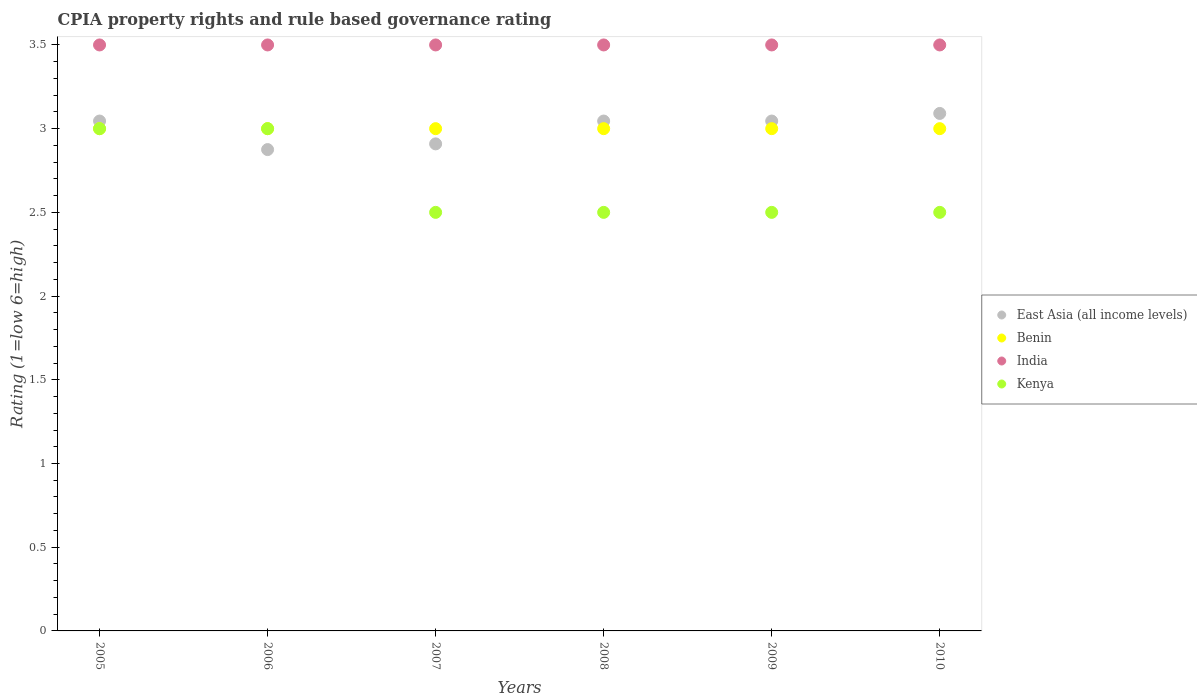Is the number of dotlines equal to the number of legend labels?
Keep it short and to the point. Yes. What is the CPIA rating in East Asia (all income levels) in 2007?
Your answer should be very brief. 2.91. Across all years, what is the maximum CPIA rating in Kenya?
Make the answer very short. 3. Across all years, what is the minimum CPIA rating in Kenya?
Ensure brevity in your answer.  2.5. In which year was the CPIA rating in Kenya maximum?
Make the answer very short. 2005. In which year was the CPIA rating in Benin minimum?
Your response must be concise. 2005. What is the total CPIA rating in Benin in the graph?
Ensure brevity in your answer.  18. In how many years, is the CPIA rating in Kenya greater than 1.5?
Provide a short and direct response. 6. What is the ratio of the CPIA rating in East Asia (all income levels) in 2006 to that in 2008?
Offer a very short reply. 0.94. What is the difference between the highest and the second highest CPIA rating in India?
Offer a terse response. 0. What is the difference between the highest and the lowest CPIA rating in Benin?
Provide a succinct answer. 0. In how many years, is the CPIA rating in Kenya greater than the average CPIA rating in Kenya taken over all years?
Ensure brevity in your answer.  2. Is the CPIA rating in Kenya strictly greater than the CPIA rating in East Asia (all income levels) over the years?
Your answer should be compact. No. How many dotlines are there?
Offer a very short reply. 4. Are the values on the major ticks of Y-axis written in scientific E-notation?
Give a very brief answer. No. Where does the legend appear in the graph?
Your answer should be compact. Center right. How are the legend labels stacked?
Offer a very short reply. Vertical. What is the title of the graph?
Your answer should be compact. CPIA property rights and rule based governance rating. Does "China" appear as one of the legend labels in the graph?
Ensure brevity in your answer.  No. What is the label or title of the X-axis?
Give a very brief answer. Years. What is the label or title of the Y-axis?
Offer a terse response. Rating (1=low 6=high). What is the Rating (1=low 6=high) in East Asia (all income levels) in 2005?
Offer a terse response. 3.05. What is the Rating (1=low 6=high) of Benin in 2005?
Your answer should be very brief. 3. What is the Rating (1=low 6=high) of India in 2005?
Ensure brevity in your answer.  3.5. What is the Rating (1=low 6=high) of Kenya in 2005?
Your answer should be very brief. 3. What is the Rating (1=low 6=high) of East Asia (all income levels) in 2006?
Your answer should be compact. 2.88. What is the Rating (1=low 6=high) in Benin in 2006?
Your answer should be compact. 3. What is the Rating (1=low 6=high) of Kenya in 2006?
Ensure brevity in your answer.  3. What is the Rating (1=low 6=high) of East Asia (all income levels) in 2007?
Provide a succinct answer. 2.91. What is the Rating (1=low 6=high) of India in 2007?
Make the answer very short. 3.5. What is the Rating (1=low 6=high) in Kenya in 2007?
Ensure brevity in your answer.  2.5. What is the Rating (1=low 6=high) in East Asia (all income levels) in 2008?
Make the answer very short. 3.05. What is the Rating (1=low 6=high) in East Asia (all income levels) in 2009?
Make the answer very short. 3.05. What is the Rating (1=low 6=high) of Benin in 2009?
Ensure brevity in your answer.  3. What is the Rating (1=low 6=high) in India in 2009?
Make the answer very short. 3.5. What is the Rating (1=low 6=high) of East Asia (all income levels) in 2010?
Keep it short and to the point. 3.09. What is the Rating (1=low 6=high) of Benin in 2010?
Offer a very short reply. 3. What is the Rating (1=low 6=high) of India in 2010?
Offer a very short reply. 3.5. What is the Rating (1=low 6=high) in Kenya in 2010?
Give a very brief answer. 2.5. Across all years, what is the maximum Rating (1=low 6=high) of East Asia (all income levels)?
Make the answer very short. 3.09. Across all years, what is the maximum Rating (1=low 6=high) in Kenya?
Provide a short and direct response. 3. Across all years, what is the minimum Rating (1=low 6=high) in East Asia (all income levels)?
Keep it short and to the point. 2.88. Across all years, what is the minimum Rating (1=low 6=high) in Benin?
Offer a terse response. 3. Across all years, what is the minimum Rating (1=low 6=high) in India?
Ensure brevity in your answer.  3.5. Across all years, what is the minimum Rating (1=low 6=high) in Kenya?
Offer a very short reply. 2.5. What is the total Rating (1=low 6=high) in East Asia (all income levels) in the graph?
Offer a very short reply. 18.01. What is the total Rating (1=low 6=high) in Benin in the graph?
Your answer should be very brief. 18. What is the total Rating (1=low 6=high) of India in the graph?
Offer a terse response. 21. What is the total Rating (1=low 6=high) in Kenya in the graph?
Offer a very short reply. 16. What is the difference between the Rating (1=low 6=high) in East Asia (all income levels) in 2005 and that in 2006?
Make the answer very short. 0.17. What is the difference between the Rating (1=low 6=high) of India in 2005 and that in 2006?
Provide a succinct answer. 0. What is the difference between the Rating (1=low 6=high) of East Asia (all income levels) in 2005 and that in 2007?
Your response must be concise. 0.14. What is the difference between the Rating (1=low 6=high) in Benin in 2005 and that in 2007?
Make the answer very short. 0. What is the difference between the Rating (1=low 6=high) of India in 2005 and that in 2007?
Give a very brief answer. 0. What is the difference between the Rating (1=low 6=high) of Kenya in 2005 and that in 2007?
Your answer should be compact. 0.5. What is the difference between the Rating (1=low 6=high) of India in 2005 and that in 2008?
Offer a terse response. 0. What is the difference between the Rating (1=low 6=high) in Kenya in 2005 and that in 2008?
Your answer should be very brief. 0.5. What is the difference between the Rating (1=low 6=high) of East Asia (all income levels) in 2005 and that in 2009?
Ensure brevity in your answer.  0. What is the difference between the Rating (1=low 6=high) of Benin in 2005 and that in 2009?
Your response must be concise. 0. What is the difference between the Rating (1=low 6=high) of East Asia (all income levels) in 2005 and that in 2010?
Keep it short and to the point. -0.05. What is the difference between the Rating (1=low 6=high) of East Asia (all income levels) in 2006 and that in 2007?
Provide a succinct answer. -0.03. What is the difference between the Rating (1=low 6=high) of Benin in 2006 and that in 2007?
Ensure brevity in your answer.  0. What is the difference between the Rating (1=low 6=high) in Kenya in 2006 and that in 2007?
Offer a very short reply. 0.5. What is the difference between the Rating (1=low 6=high) of East Asia (all income levels) in 2006 and that in 2008?
Provide a short and direct response. -0.17. What is the difference between the Rating (1=low 6=high) in India in 2006 and that in 2008?
Offer a very short reply. 0. What is the difference between the Rating (1=low 6=high) in Kenya in 2006 and that in 2008?
Ensure brevity in your answer.  0.5. What is the difference between the Rating (1=low 6=high) of East Asia (all income levels) in 2006 and that in 2009?
Offer a very short reply. -0.17. What is the difference between the Rating (1=low 6=high) in East Asia (all income levels) in 2006 and that in 2010?
Make the answer very short. -0.22. What is the difference between the Rating (1=low 6=high) in Kenya in 2006 and that in 2010?
Give a very brief answer. 0.5. What is the difference between the Rating (1=low 6=high) of East Asia (all income levels) in 2007 and that in 2008?
Provide a short and direct response. -0.14. What is the difference between the Rating (1=low 6=high) in Benin in 2007 and that in 2008?
Provide a short and direct response. 0. What is the difference between the Rating (1=low 6=high) in India in 2007 and that in 2008?
Keep it short and to the point. 0. What is the difference between the Rating (1=low 6=high) of Kenya in 2007 and that in 2008?
Offer a very short reply. 0. What is the difference between the Rating (1=low 6=high) of East Asia (all income levels) in 2007 and that in 2009?
Your response must be concise. -0.14. What is the difference between the Rating (1=low 6=high) in Benin in 2007 and that in 2009?
Keep it short and to the point. 0. What is the difference between the Rating (1=low 6=high) in Kenya in 2007 and that in 2009?
Offer a very short reply. 0. What is the difference between the Rating (1=low 6=high) in East Asia (all income levels) in 2007 and that in 2010?
Ensure brevity in your answer.  -0.18. What is the difference between the Rating (1=low 6=high) of Kenya in 2007 and that in 2010?
Offer a terse response. 0. What is the difference between the Rating (1=low 6=high) in Benin in 2008 and that in 2009?
Offer a very short reply. 0. What is the difference between the Rating (1=low 6=high) in India in 2008 and that in 2009?
Keep it short and to the point. 0. What is the difference between the Rating (1=low 6=high) of East Asia (all income levels) in 2008 and that in 2010?
Offer a terse response. -0.05. What is the difference between the Rating (1=low 6=high) of Benin in 2008 and that in 2010?
Keep it short and to the point. 0. What is the difference between the Rating (1=low 6=high) in India in 2008 and that in 2010?
Your answer should be very brief. 0. What is the difference between the Rating (1=low 6=high) of Kenya in 2008 and that in 2010?
Provide a short and direct response. 0. What is the difference between the Rating (1=low 6=high) of East Asia (all income levels) in 2009 and that in 2010?
Keep it short and to the point. -0.05. What is the difference between the Rating (1=low 6=high) of India in 2009 and that in 2010?
Offer a very short reply. 0. What is the difference between the Rating (1=low 6=high) of Kenya in 2009 and that in 2010?
Give a very brief answer. 0. What is the difference between the Rating (1=low 6=high) in East Asia (all income levels) in 2005 and the Rating (1=low 6=high) in Benin in 2006?
Provide a short and direct response. 0.05. What is the difference between the Rating (1=low 6=high) in East Asia (all income levels) in 2005 and the Rating (1=low 6=high) in India in 2006?
Ensure brevity in your answer.  -0.45. What is the difference between the Rating (1=low 6=high) of East Asia (all income levels) in 2005 and the Rating (1=low 6=high) of Kenya in 2006?
Your answer should be very brief. 0.05. What is the difference between the Rating (1=low 6=high) of Benin in 2005 and the Rating (1=low 6=high) of India in 2006?
Provide a short and direct response. -0.5. What is the difference between the Rating (1=low 6=high) of East Asia (all income levels) in 2005 and the Rating (1=low 6=high) of Benin in 2007?
Your answer should be very brief. 0.05. What is the difference between the Rating (1=low 6=high) of East Asia (all income levels) in 2005 and the Rating (1=low 6=high) of India in 2007?
Give a very brief answer. -0.45. What is the difference between the Rating (1=low 6=high) of East Asia (all income levels) in 2005 and the Rating (1=low 6=high) of Kenya in 2007?
Make the answer very short. 0.55. What is the difference between the Rating (1=low 6=high) of East Asia (all income levels) in 2005 and the Rating (1=low 6=high) of Benin in 2008?
Keep it short and to the point. 0.05. What is the difference between the Rating (1=low 6=high) in East Asia (all income levels) in 2005 and the Rating (1=low 6=high) in India in 2008?
Ensure brevity in your answer.  -0.45. What is the difference between the Rating (1=low 6=high) in East Asia (all income levels) in 2005 and the Rating (1=low 6=high) in Kenya in 2008?
Your response must be concise. 0.55. What is the difference between the Rating (1=low 6=high) of Benin in 2005 and the Rating (1=low 6=high) of Kenya in 2008?
Provide a succinct answer. 0.5. What is the difference between the Rating (1=low 6=high) of East Asia (all income levels) in 2005 and the Rating (1=low 6=high) of Benin in 2009?
Your answer should be compact. 0.05. What is the difference between the Rating (1=low 6=high) of East Asia (all income levels) in 2005 and the Rating (1=low 6=high) of India in 2009?
Offer a terse response. -0.45. What is the difference between the Rating (1=low 6=high) of East Asia (all income levels) in 2005 and the Rating (1=low 6=high) of Kenya in 2009?
Provide a short and direct response. 0.55. What is the difference between the Rating (1=low 6=high) of Benin in 2005 and the Rating (1=low 6=high) of Kenya in 2009?
Offer a terse response. 0.5. What is the difference between the Rating (1=low 6=high) in India in 2005 and the Rating (1=low 6=high) in Kenya in 2009?
Make the answer very short. 1. What is the difference between the Rating (1=low 6=high) of East Asia (all income levels) in 2005 and the Rating (1=low 6=high) of Benin in 2010?
Give a very brief answer. 0.05. What is the difference between the Rating (1=low 6=high) in East Asia (all income levels) in 2005 and the Rating (1=low 6=high) in India in 2010?
Give a very brief answer. -0.45. What is the difference between the Rating (1=low 6=high) of East Asia (all income levels) in 2005 and the Rating (1=low 6=high) of Kenya in 2010?
Offer a very short reply. 0.55. What is the difference between the Rating (1=low 6=high) of Benin in 2005 and the Rating (1=low 6=high) of India in 2010?
Keep it short and to the point. -0.5. What is the difference between the Rating (1=low 6=high) in Benin in 2005 and the Rating (1=low 6=high) in Kenya in 2010?
Ensure brevity in your answer.  0.5. What is the difference between the Rating (1=low 6=high) in East Asia (all income levels) in 2006 and the Rating (1=low 6=high) in Benin in 2007?
Your answer should be very brief. -0.12. What is the difference between the Rating (1=low 6=high) of East Asia (all income levels) in 2006 and the Rating (1=low 6=high) of India in 2007?
Give a very brief answer. -0.62. What is the difference between the Rating (1=low 6=high) of East Asia (all income levels) in 2006 and the Rating (1=low 6=high) of Kenya in 2007?
Your response must be concise. 0.38. What is the difference between the Rating (1=low 6=high) of India in 2006 and the Rating (1=low 6=high) of Kenya in 2007?
Ensure brevity in your answer.  1. What is the difference between the Rating (1=low 6=high) of East Asia (all income levels) in 2006 and the Rating (1=low 6=high) of Benin in 2008?
Give a very brief answer. -0.12. What is the difference between the Rating (1=low 6=high) of East Asia (all income levels) in 2006 and the Rating (1=low 6=high) of India in 2008?
Keep it short and to the point. -0.62. What is the difference between the Rating (1=low 6=high) of Benin in 2006 and the Rating (1=low 6=high) of Kenya in 2008?
Provide a short and direct response. 0.5. What is the difference between the Rating (1=low 6=high) of East Asia (all income levels) in 2006 and the Rating (1=low 6=high) of Benin in 2009?
Provide a short and direct response. -0.12. What is the difference between the Rating (1=low 6=high) in East Asia (all income levels) in 2006 and the Rating (1=low 6=high) in India in 2009?
Make the answer very short. -0.62. What is the difference between the Rating (1=low 6=high) of Benin in 2006 and the Rating (1=low 6=high) of Kenya in 2009?
Your answer should be very brief. 0.5. What is the difference between the Rating (1=low 6=high) of India in 2006 and the Rating (1=low 6=high) of Kenya in 2009?
Your answer should be compact. 1. What is the difference between the Rating (1=low 6=high) in East Asia (all income levels) in 2006 and the Rating (1=low 6=high) in Benin in 2010?
Offer a terse response. -0.12. What is the difference between the Rating (1=low 6=high) of East Asia (all income levels) in 2006 and the Rating (1=low 6=high) of India in 2010?
Offer a terse response. -0.62. What is the difference between the Rating (1=low 6=high) in Benin in 2006 and the Rating (1=low 6=high) in India in 2010?
Ensure brevity in your answer.  -0.5. What is the difference between the Rating (1=low 6=high) in Benin in 2006 and the Rating (1=low 6=high) in Kenya in 2010?
Provide a succinct answer. 0.5. What is the difference between the Rating (1=low 6=high) of East Asia (all income levels) in 2007 and the Rating (1=low 6=high) of Benin in 2008?
Your answer should be compact. -0.09. What is the difference between the Rating (1=low 6=high) in East Asia (all income levels) in 2007 and the Rating (1=low 6=high) in India in 2008?
Provide a succinct answer. -0.59. What is the difference between the Rating (1=low 6=high) of East Asia (all income levels) in 2007 and the Rating (1=low 6=high) of Kenya in 2008?
Keep it short and to the point. 0.41. What is the difference between the Rating (1=low 6=high) of Benin in 2007 and the Rating (1=low 6=high) of Kenya in 2008?
Make the answer very short. 0.5. What is the difference between the Rating (1=low 6=high) in East Asia (all income levels) in 2007 and the Rating (1=low 6=high) in Benin in 2009?
Give a very brief answer. -0.09. What is the difference between the Rating (1=low 6=high) of East Asia (all income levels) in 2007 and the Rating (1=low 6=high) of India in 2009?
Ensure brevity in your answer.  -0.59. What is the difference between the Rating (1=low 6=high) of East Asia (all income levels) in 2007 and the Rating (1=low 6=high) of Kenya in 2009?
Make the answer very short. 0.41. What is the difference between the Rating (1=low 6=high) in Benin in 2007 and the Rating (1=low 6=high) in India in 2009?
Your answer should be compact. -0.5. What is the difference between the Rating (1=low 6=high) in Benin in 2007 and the Rating (1=low 6=high) in Kenya in 2009?
Your answer should be compact. 0.5. What is the difference between the Rating (1=low 6=high) in India in 2007 and the Rating (1=low 6=high) in Kenya in 2009?
Keep it short and to the point. 1. What is the difference between the Rating (1=low 6=high) of East Asia (all income levels) in 2007 and the Rating (1=low 6=high) of Benin in 2010?
Your answer should be very brief. -0.09. What is the difference between the Rating (1=low 6=high) in East Asia (all income levels) in 2007 and the Rating (1=low 6=high) in India in 2010?
Offer a terse response. -0.59. What is the difference between the Rating (1=low 6=high) of East Asia (all income levels) in 2007 and the Rating (1=low 6=high) of Kenya in 2010?
Keep it short and to the point. 0.41. What is the difference between the Rating (1=low 6=high) of Benin in 2007 and the Rating (1=low 6=high) of India in 2010?
Offer a terse response. -0.5. What is the difference between the Rating (1=low 6=high) of India in 2007 and the Rating (1=low 6=high) of Kenya in 2010?
Provide a succinct answer. 1. What is the difference between the Rating (1=low 6=high) in East Asia (all income levels) in 2008 and the Rating (1=low 6=high) in Benin in 2009?
Your answer should be very brief. 0.05. What is the difference between the Rating (1=low 6=high) of East Asia (all income levels) in 2008 and the Rating (1=low 6=high) of India in 2009?
Provide a short and direct response. -0.45. What is the difference between the Rating (1=low 6=high) in East Asia (all income levels) in 2008 and the Rating (1=low 6=high) in Kenya in 2009?
Offer a terse response. 0.55. What is the difference between the Rating (1=low 6=high) in Benin in 2008 and the Rating (1=low 6=high) in India in 2009?
Ensure brevity in your answer.  -0.5. What is the difference between the Rating (1=low 6=high) in Benin in 2008 and the Rating (1=low 6=high) in Kenya in 2009?
Offer a very short reply. 0.5. What is the difference between the Rating (1=low 6=high) of India in 2008 and the Rating (1=low 6=high) of Kenya in 2009?
Make the answer very short. 1. What is the difference between the Rating (1=low 6=high) in East Asia (all income levels) in 2008 and the Rating (1=low 6=high) in Benin in 2010?
Offer a terse response. 0.05. What is the difference between the Rating (1=low 6=high) in East Asia (all income levels) in 2008 and the Rating (1=low 6=high) in India in 2010?
Make the answer very short. -0.45. What is the difference between the Rating (1=low 6=high) in East Asia (all income levels) in 2008 and the Rating (1=low 6=high) in Kenya in 2010?
Provide a short and direct response. 0.55. What is the difference between the Rating (1=low 6=high) of India in 2008 and the Rating (1=low 6=high) of Kenya in 2010?
Keep it short and to the point. 1. What is the difference between the Rating (1=low 6=high) in East Asia (all income levels) in 2009 and the Rating (1=low 6=high) in Benin in 2010?
Ensure brevity in your answer.  0.05. What is the difference between the Rating (1=low 6=high) in East Asia (all income levels) in 2009 and the Rating (1=low 6=high) in India in 2010?
Give a very brief answer. -0.45. What is the difference between the Rating (1=low 6=high) of East Asia (all income levels) in 2009 and the Rating (1=low 6=high) of Kenya in 2010?
Offer a terse response. 0.55. What is the difference between the Rating (1=low 6=high) in Benin in 2009 and the Rating (1=low 6=high) in India in 2010?
Ensure brevity in your answer.  -0.5. What is the difference between the Rating (1=low 6=high) in India in 2009 and the Rating (1=low 6=high) in Kenya in 2010?
Provide a short and direct response. 1. What is the average Rating (1=low 6=high) of East Asia (all income levels) per year?
Offer a very short reply. 3. What is the average Rating (1=low 6=high) of Kenya per year?
Your answer should be very brief. 2.67. In the year 2005, what is the difference between the Rating (1=low 6=high) in East Asia (all income levels) and Rating (1=low 6=high) in Benin?
Your answer should be very brief. 0.05. In the year 2005, what is the difference between the Rating (1=low 6=high) of East Asia (all income levels) and Rating (1=low 6=high) of India?
Make the answer very short. -0.45. In the year 2005, what is the difference between the Rating (1=low 6=high) of East Asia (all income levels) and Rating (1=low 6=high) of Kenya?
Give a very brief answer. 0.05. In the year 2005, what is the difference between the Rating (1=low 6=high) of Benin and Rating (1=low 6=high) of Kenya?
Provide a short and direct response. 0. In the year 2005, what is the difference between the Rating (1=low 6=high) of India and Rating (1=low 6=high) of Kenya?
Your answer should be very brief. 0.5. In the year 2006, what is the difference between the Rating (1=low 6=high) in East Asia (all income levels) and Rating (1=low 6=high) in Benin?
Provide a succinct answer. -0.12. In the year 2006, what is the difference between the Rating (1=low 6=high) in East Asia (all income levels) and Rating (1=low 6=high) in India?
Offer a very short reply. -0.62. In the year 2006, what is the difference between the Rating (1=low 6=high) of East Asia (all income levels) and Rating (1=low 6=high) of Kenya?
Provide a short and direct response. -0.12. In the year 2006, what is the difference between the Rating (1=low 6=high) of Benin and Rating (1=low 6=high) of Kenya?
Offer a terse response. 0. In the year 2007, what is the difference between the Rating (1=low 6=high) of East Asia (all income levels) and Rating (1=low 6=high) of Benin?
Provide a succinct answer. -0.09. In the year 2007, what is the difference between the Rating (1=low 6=high) in East Asia (all income levels) and Rating (1=low 6=high) in India?
Ensure brevity in your answer.  -0.59. In the year 2007, what is the difference between the Rating (1=low 6=high) of East Asia (all income levels) and Rating (1=low 6=high) of Kenya?
Provide a short and direct response. 0.41. In the year 2007, what is the difference between the Rating (1=low 6=high) in Benin and Rating (1=low 6=high) in India?
Your answer should be very brief. -0.5. In the year 2008, what is the difference between the Rating (1=low 6=high) in East Asia (all income levels) and Rating (1=low 6=high) in Benin?
Make the answer very short. 0.05. In the year 2008, what is the difference between the Rating (1=low 6=high) of East Asia (all income levels) and Rating (1=low 6=high) of India?
Ensure brevity in your answer.  -0.45. In the year 2008, what is the difference between the Rating (1=low 6=high) of East Asia (all income levels) and Rating (1=low 6=high) of Kenya?
Make the answer very short. 0.55. In the year 2008, what is the difference between the Rating (1=low 6=high) of India and Rating (1=low 6=high) of Kenya?
Your response must be concise. 1. In the year 2009, what is the difference between the Rating (1=low 6=high) of East Asia (all income levels) and Rating (1=low 6=high) of Benin?
Give a very brief answer. 0.05. In the year 2009, what is the difference between the Rating (1=low 6=high) of East Asia (all income levels) and Rating (1=low 6=high) of India?
Provide a succinct answer. -0.45. In the year 2009, what is the difference between the Rating (1=low 6=high) of East Asia (all income levels) and Rating (1=low 6=high) of Kenya?
Keep it short and to the point. 0.55. In the year 2009, what is the difference between the Rating (1=low 6=high) of Benin and Rating (1=low 6=high) of India?
Keep it short and to the point. -0.5. In the year 2009, what is the difference between the Rating (1=low 6=high) of Benin and Rating (1=low 6=high) of Kenya?
Give a very brief answer. 0.5. In the year 2010, what is the difference between the Rating (1=low 6=high) in East Asia (all income levels) and Rating (1=low 6=high) in Benin?
Your response must be concise. 0.09. In the year 2010, what is the difference between the Rating (1=low 6=high) in East Asia (all income levels) and Rating (1=low 6=high) in India?
Your answer should be compact. -0.41. In the year 2010, what is the difference between the Rating (1=low 6=high) in East Asia (all income levels) and Rating (1=low 6=high) in Kenya?
Your answer should be very brief. 0.59. In the year 2010, what is the difference between the Rating (1=low 6=high) of Benin and Rating (1=low 6=high) of India?
Your response must be concise. -0.5. In the year 2010, what is the difference between the Rating (1=low 6=high) of Benin and Rating (1=low 6=high) of Kenya?
Provide a succinct answer. 0.5. What is the ratio of the Rating (1=low 6=high) of East Asia (all income levels) in 2005 to that in 2006?
Ensure brevity in your answer.  1.06. What is the ratio of the Rating (1=low 6=high) in India in 2005 to that in 2006?
Your answer should be very brief. 1. What is the ratio of the Rating (1=low 6=high) of Kenya in 2005 to that in 2006?
Offer a very short reply. 1. What is the ratio of the Rating (1=low 6=high) of East Asia (all income levels) in 2005 to that in 2007?
Give a very brief answer. 1.05. What is the ratio of the Rating (1=low 6=high) of Benin in 2005 to that in 2007?
Your answer should be compact. 1. What is the ratio of the Rating (1=low 6=high) of India in 2005 to that in 2007?
Your answer should be compact. 1. What is the ratio of the Rating (1=low 6=high) in Kenya in 2005 to that in 2007?
Offer a very short reply. 1.2. What is the ratio of the Rating (1=low 6=high) of East Asia (all income levels) in 2005 to that in 2008?
Keep it short and to the point. 1. What is the ratio of the Rating (1=low 6=high) in Benin in 2005 to that in 2009?
Your answer should be compact. 1. What is the ratio of the Rating (1=low 6=high) of India in 2005 to that in 2009?
Your answer should be very brief. 1. What is the ratio of the Rating (1=low 6=high) of Kenya in 2005 to that in 2009?
Your answer should be very brief. 1.2. What is the ratio of the Rating (1=low 6=high) of East Asia (all income levels) in 2005 to that in 2010?
Provide a short and direct response. 0.99. What is the ratio of the Rating (1=low 6=high) in Benin in 2005 to that in 2010?
Offer a very short reply. 1. What is the ratio of the Rating (1=low 6=high) in India in 2005 to that in 2010?
Keep it short and to the point. 1. What is the ratio of the Rating (1=low 6=high) in East Asia (all income levels) in 2006 to that in 2007?
Keep it short and to the point. 0.99. What is the ratio of the Rating (1=low 6=high) in East Asia (all income levels) in 2006 to that in 2008?
Ensure brevity in your answer.  0.94. What is the ratio of the Rating (1=low 6=high) of East Asia (all income levels) in 2006 to that in 2009?
Your response must be concise. 0.94. What is the ratio of the Rating (1=low 6=high) of Kenya in 2006 to that in 2009?
Give a very brief answer. 1.2. What is the ratio of the Rating (1=low 6=high) of East Asia (all income levels) in 2006 to that in 2010?
Your response must be concise. 0.93. What is the ratio of the Rating (1=low 6=high) in Benin in 2006 to that in 2010?
Offer a very short reply. 1. What is the ratio of the Rating (1=low 6=high) of Kenya in 2006 to that in 2010?
Your response must be concise. 1.2. What is the ratio of the Rating (1=low 6=high) of East Asia (all income levels) in 2007 to that in 2008?
Offer a terse response. 0.96. What is the ratio of the Rating (1=low 6=high) of Kenya in 2007 to that in 2008?
Make the answer very short. 1. What is the ratio of the Rating (1=low 6=high) in East Asia (all income levels) in 2007 to that in 2009?
Your answer should be compact. 0.96. What is the ratio of the Rating (1=low 6=high) in Benin in 2007 to that in 2009?
Make the answer very short. 1. What is the ratio of the Rating (1=low 6=high) in Benin in 2007 to that in 2010?
Make the answer very short. 1. What is the ratio of the Rating (1=low 6=high) in East Asia (all income levels) in 2008 to that in 2009?
Your answer should be very brief. 1. What is the ratio of the Rating (1=low 6=high) of Benin in 2008 to that in 2009?
Offer a very short reply. 1. What is the ratio of the Rating (1=low 6=high) of Kenya in 2008 to that in 2009?
Ensure brevity in your answer.  1. What is the ratio of the Rating (1=low 6=high) in East Asia (all income levels) in 2008 to that in 2010?
Make the answer very short. 0.99. What is the ratio of the Rating (1=low 6=high) in India in 2008 to that in 2010?
Provide a short and direct response. 1. What is the ratio of the Rating (1=low 6=high) of Kenya in 2009 to that in 2010?
Give a very brief answer. 1. What is the difference between the highest and the second highest Rating (1=low 6=high) in East Asia (all income levels)?
Provide a short and direct response. 0.05. What is the difference between the highest and the second highest Rating (1=low 6=high) in Benin?
Make the answer very short. 0. What is the difference between the highest and the lowest Rating (1=low 6=high) in East Asia (all income levels)?
Offer a terse response. 0.22. 